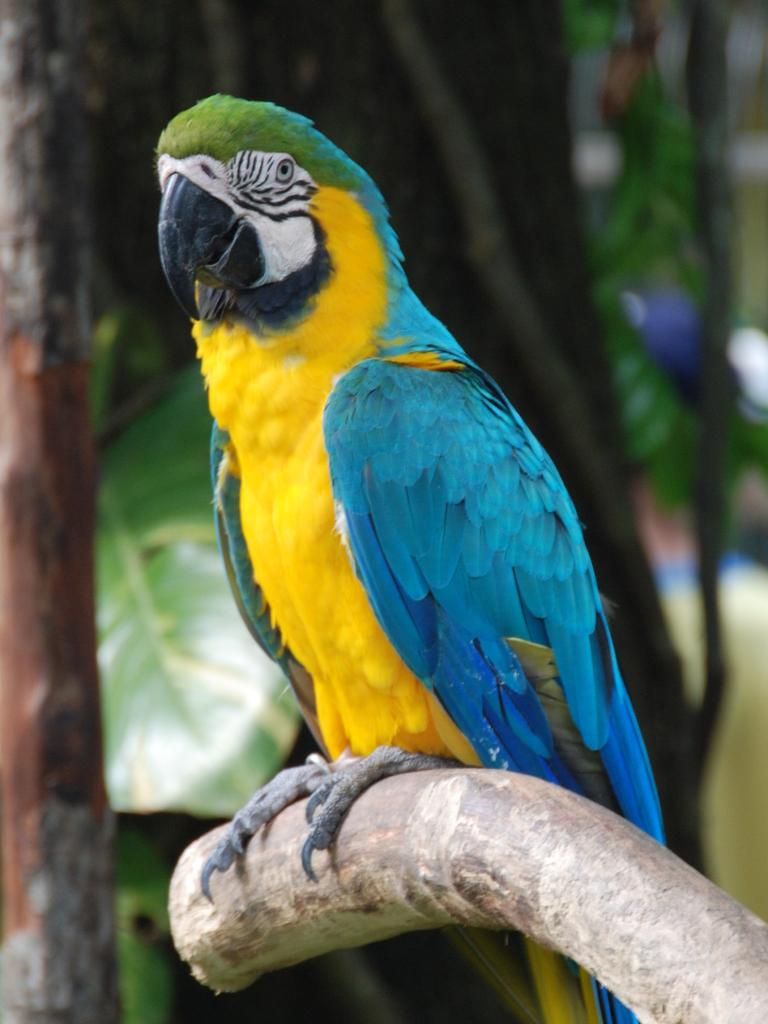What type of animal is in the image? There is a bird in the image. Where is the bird located? The bird is on tree bark. What can be seen in the background of the image? There are trees in the background of the image. What type of authority does the bird have in the image? The bird does not have any authority in the image, as it is a bird and not a person or figure of authority. 